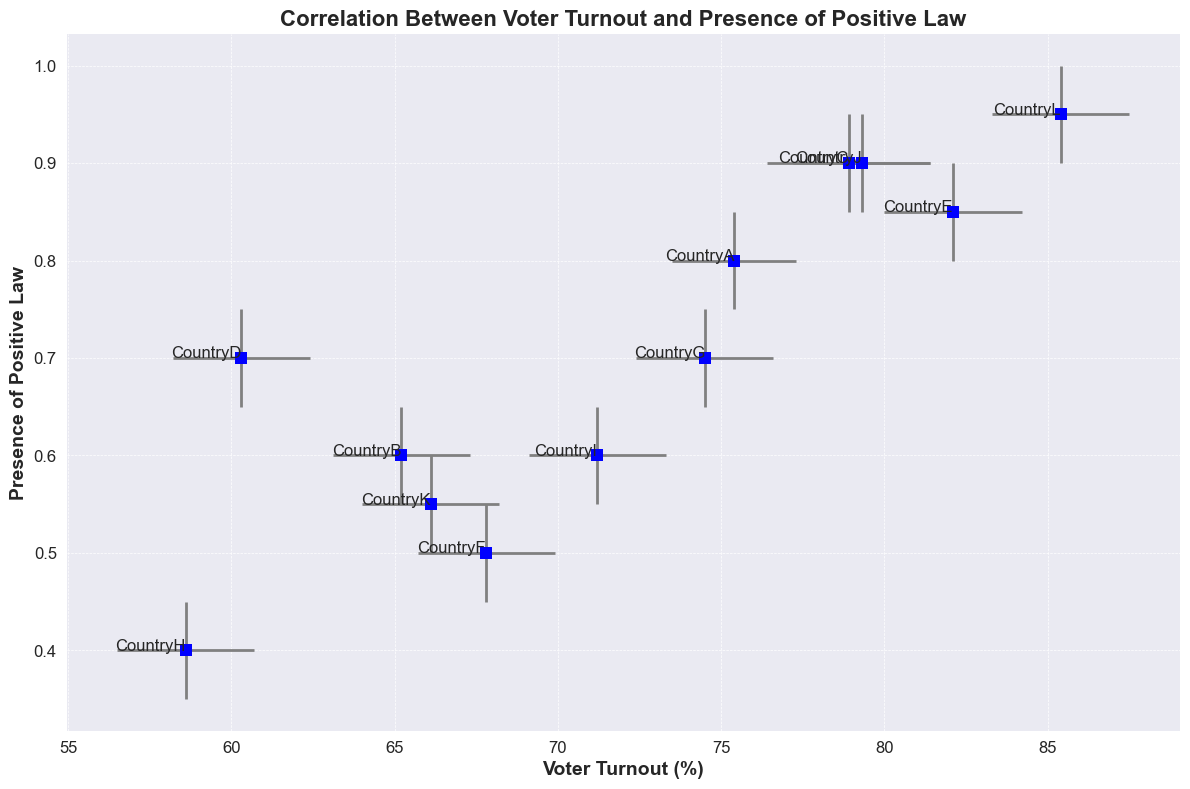What is the voter turnout range for CountryC? The voter turnout range for CountryC is determined by the lower and upper confidence intervals, which are 76.4 and 81.4, respectively. So, the range is 81.4 - 76.4 = 5.0.
Answer: 5.0 How does the voter turnout in CountryA compare to CountryH? Refer to the voter turnout values for CountryA and CountryH. CountryA has a voter turnout of 75.4%, while CountryH has a voter turnout of 58.6%, making CountryA's turnout higher.
Answer: CountryA has higher turnout Which country has the highest voter turnout? According to the chart, CountryL has the highest voter turnout with a value of 85.4%.
Answer: CountryL What is the average presence of positive law for countries with voter turnout above 80%? The countries with voter turnout above 80% are CountryE, CountryJ, and CountryL with positive law presences of 0.85, 0.9, and 0.95, respectively. The average is (0.85 + 0.9 + 0.95)/3 = 2.7/3 ≈ 0.9.
Answer: 0.9 For the country with the lowest voter turnout, what is the upper confidence interval for the presence of positive law? The country with the lowest voter turnout is CountryH, which has a positive law presence upper confidence interval of 0.45.
Answer: 0.45 Do any countries have both a voter turnout above 75% and a presence of positive laws less than 0.8? Based on the chart, no country meets both conditions: voter turnout above 75% and presence of positive laws less than 0.8.
Answer: No Calculate the mean voter turnout for countries with a positive law presence of 0.6. The countries with a positive law presence of 0.6 are CountryB and CountryI with voter turnouts of 65.2 and 71.2, respectively. The mean is (65.2 + 71.2)/2 = 136.4/2 = 68.2.
Answer: 68.2 Which country has the largest difference between the upper and lower confidence intervals for voter turnout? Check the confidence intervals for each country. CountryL has the largest range of 87.5 - 83.3 = 4.2.
Answer: CountryL 